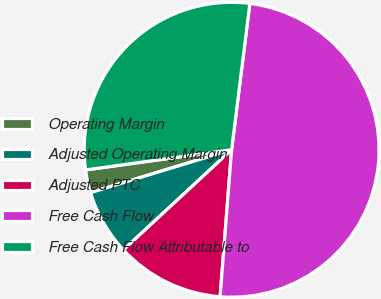<chart> <loc_0><loc_0><loc_500><loc_500><pie_chart><fcel>Operating Margin<fcel>Adjusted Operating Margin<fcel>Adjusted PTC<fcel>Free Cash Flow<fcel>Free Cash Flow Attributable to<nl><fcel>2.51%<fcel>7.19%<fcel>11.87%<fcel>49.27%<fcel>29.16%<nl></chart> 